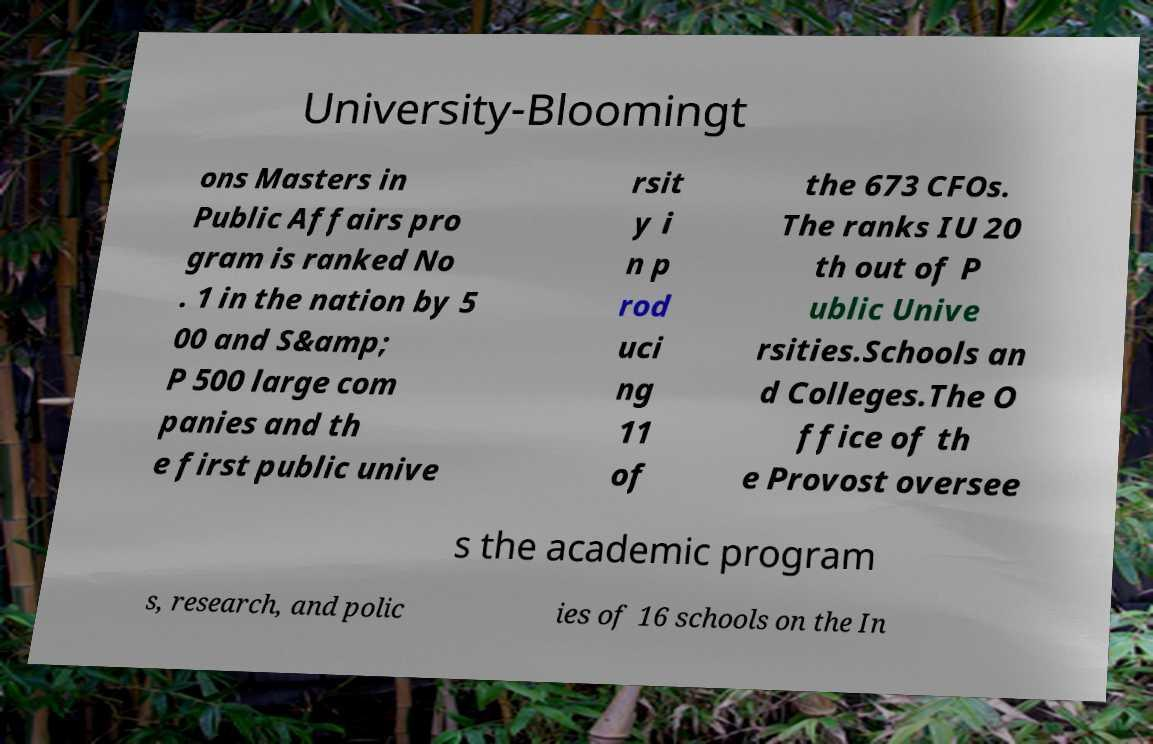What messages or text are displayed in this image? I need them in a readable, typed format. University-Bloomingt ons Masters in Public Affairs pro gram is ranked No . 1 in the nation by 5 00 and S&amp; P 500 large com panies and th e first public unive rsit y i n p rod uci ng 11 of the 673 CFOs. The ranks IU 20 th out of P ublic Unive rsities.Schools an d Colleges.The O ffice of th e Provost oversee s the academic program s, research, and polic ies of 16 schools on the In 